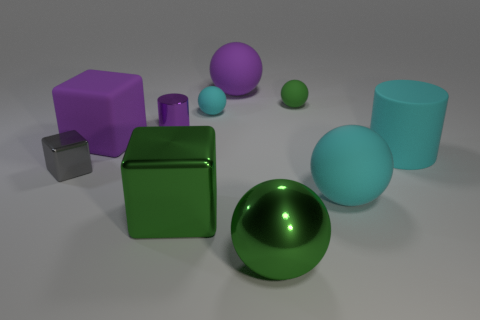Subtract all metal cubes. How many cubes are left? 1 Subtract all purple blocks. How many blocks are left? 2 Subtract 1 cubes. How many cubes are left? 2 Subtract 0 blue cylinders. How many objects are left? 10 Subtract all cubes. How many objects are left? 7 Subtract all purple balls. Subtract all cyan cylinders. How many balls are left? 4 Subtract all blue cubes. How many cyan cylinders are left? 1 Subtract all large gray metallic balls. Subtract all big green objects. How many objects are left? 8 Add 7 large green spheres. How many large green spheres are left? 8 Add 8 big blocks. How many big blocks exist? 10 